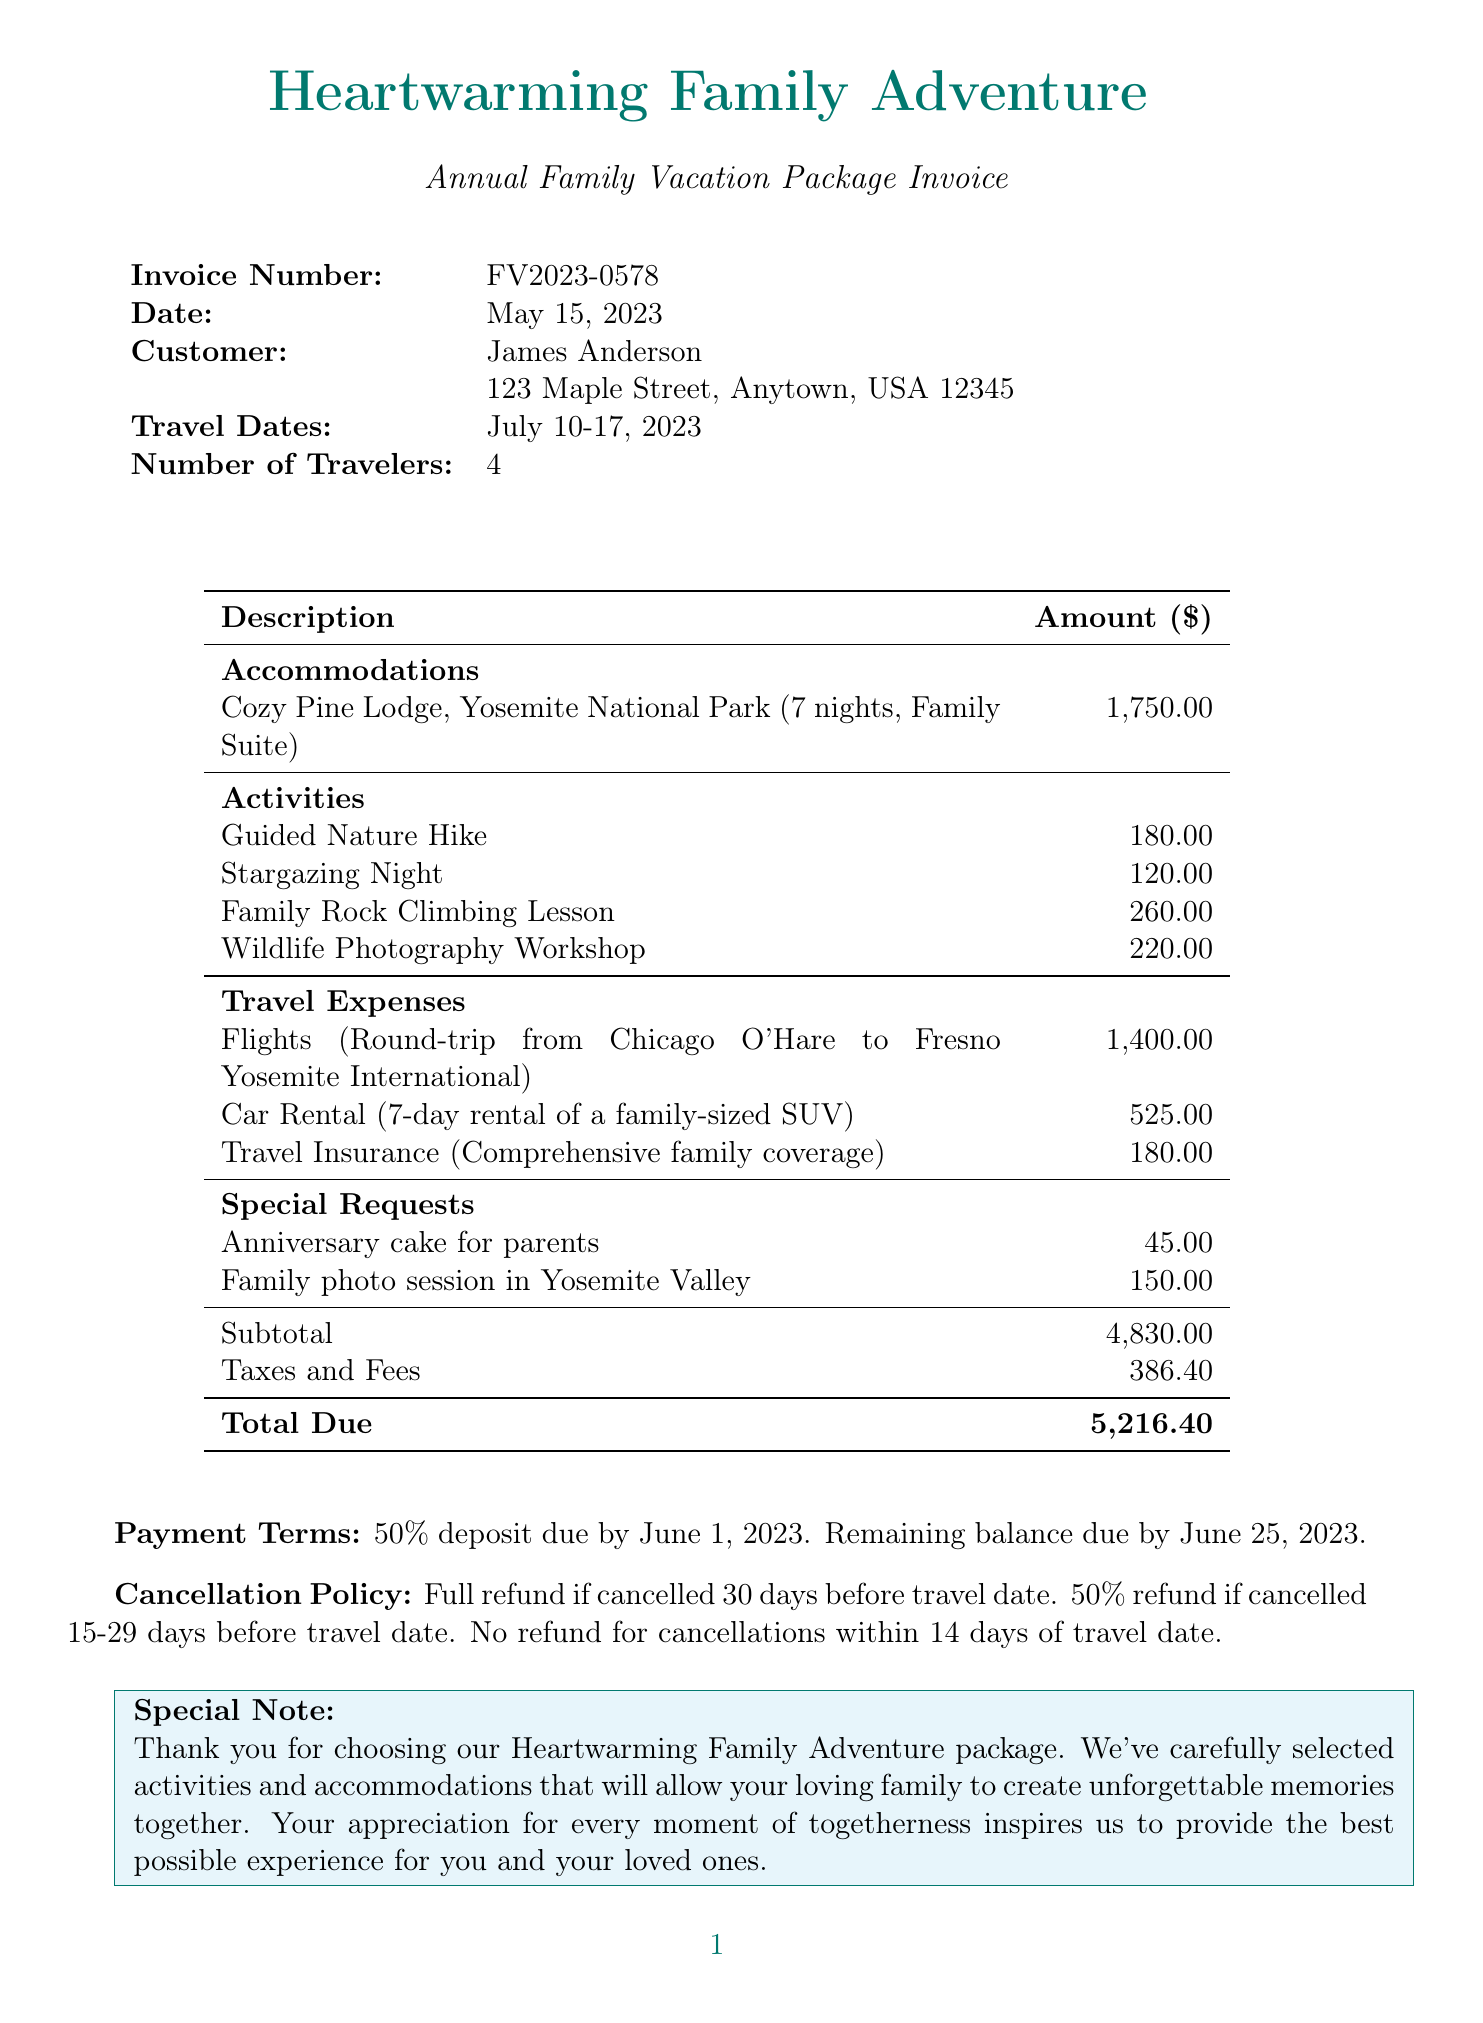What is the invoice number? The invoice number can be found in the header section of the document.
Answer: FV2023-0578 Who is the customer? The customer's name is specified alongside their address in the document.
Answer: James Anderson What are the travel dates? The travel dates are mentioned in the details section of the invoice.
Answer: July 10-17, 2023 What is the total due amount? The total due amount is the final figure presented at the end of the invoice's financial overview.
Answer: 5,216.40 How many nights will the family stay? The number of nights is detailed in the accommodations section of the invoice.
Answer: 7 What is the price per night for the accommodation? The price per night is listed under the accommodations section for the Cozy Pine Lodge.
Answer: 250 What is the cancellation policy? The cancellation policy outlines the refund conditions based on the timing of cancellation and is clearly noted in the invoice.
Answer: Full refund if cancelled 30 days before travel date What special request was made for the parents? The special requests for the family are detailed towards the end of the invoice.
Answer: Anniversary cake for parents How many total travelers are there? The number of travelers is stated in the introductory section of the document.
Answer: 4 